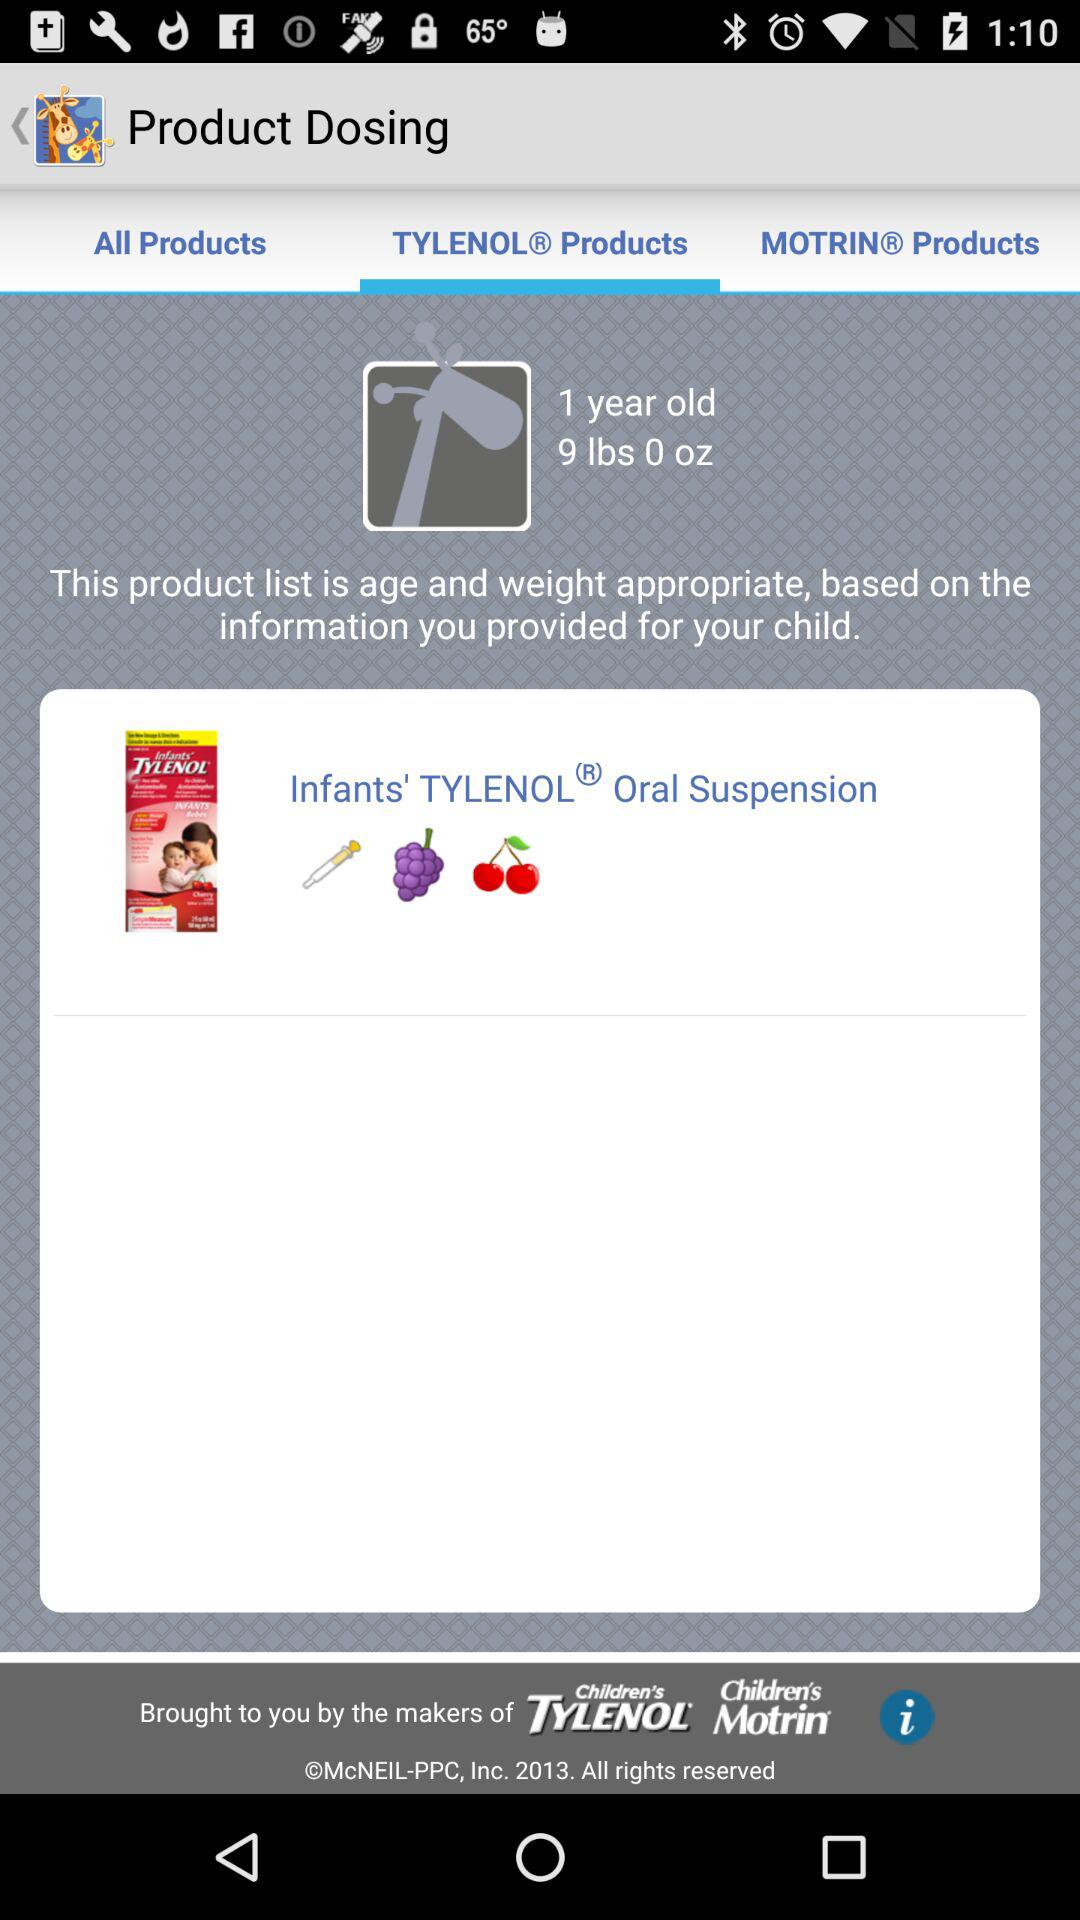Which tab has been selected? The tab that has been selected is "TYLENOL Products". 